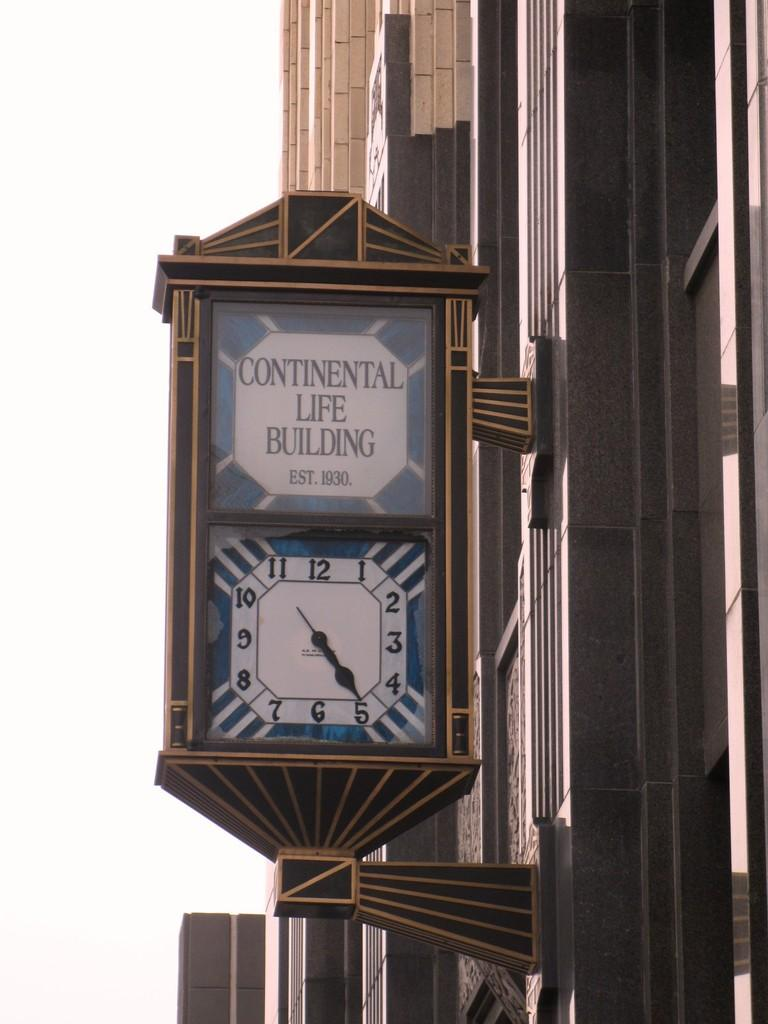<image>
Summarize the visual content of the image. The Continental Life Building is 89 years old. 